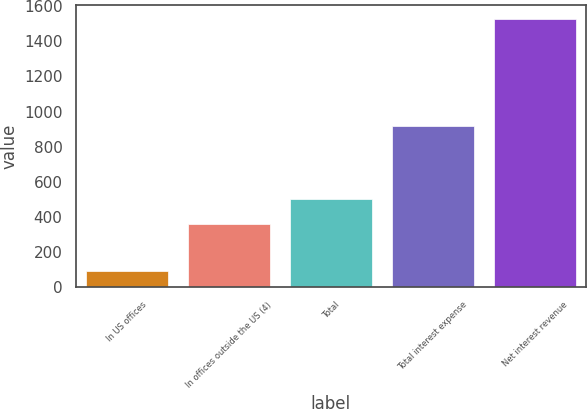Convert chart to OTSL. <chart><loc_0><loc_0><loc_500><loc_500><bar_chart><fcel>In US offices<fcel>In offices outside the US (4)<fcel>Total<fcel>Total interest expense<fcel>Net interest revenue<nl><fcel>91<fcel>358<fcel>501.7<fcel>918<fcel>1528<nl></chart> 